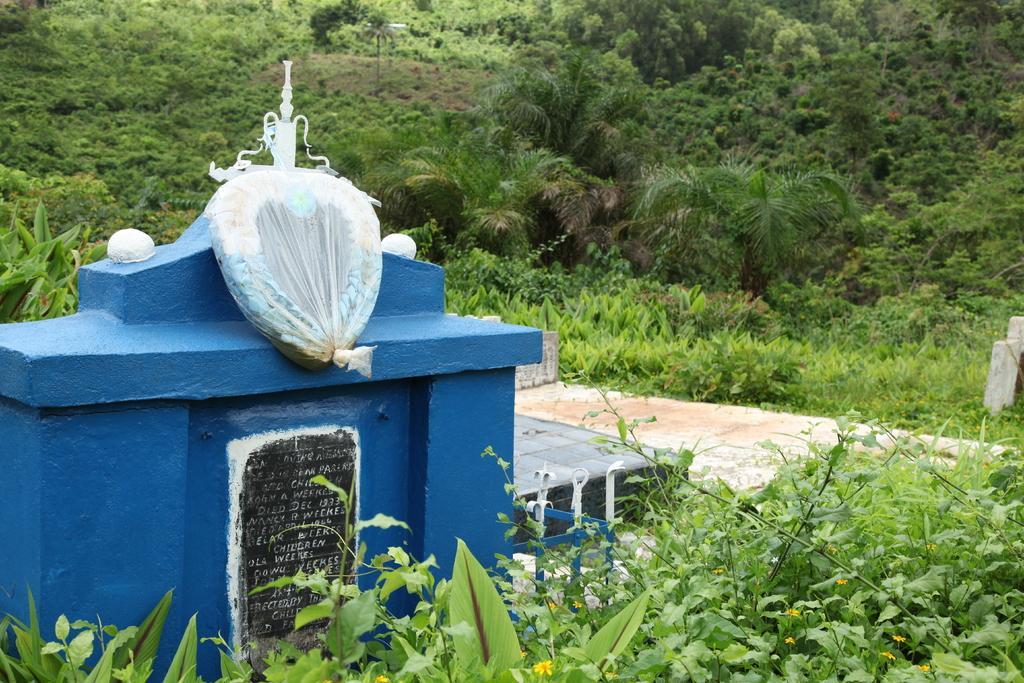Describe this image in one or two sentences. As we can see in the image there are lot of greenery like plants and trees. In between there is a grave which is in blue colour and there is a tile over here which is in black colour and there are lot of plants on the grave. 